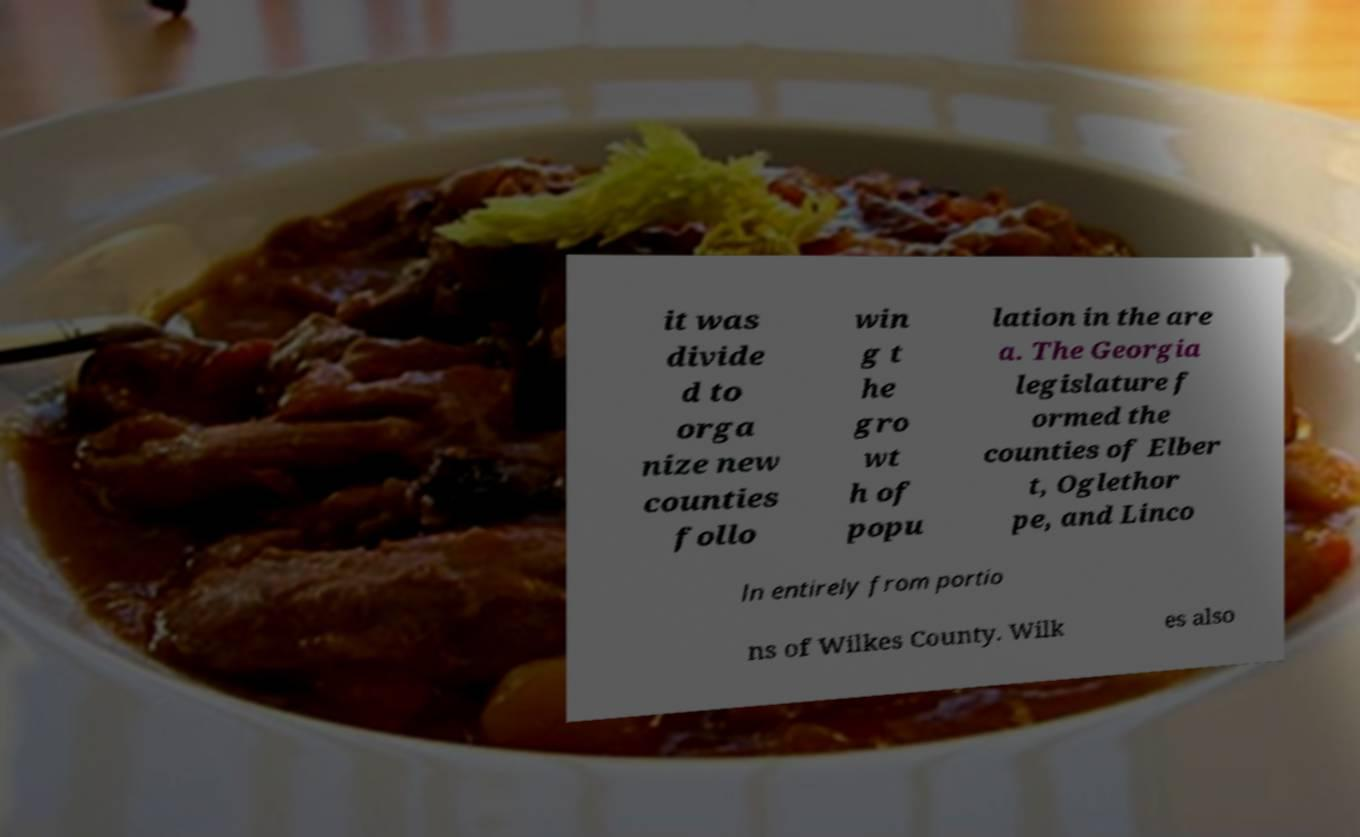I need the written content from this picture converted into text. Can you do that? it was divide d to orga nize new counties follo win g t he gro wt h of popu lation in the are a. The Georgia legislature f ormed the counties of Elber t, Oglethor pe, and Linco ln entirely from portio ns of Wilkes County. Wilk es also 